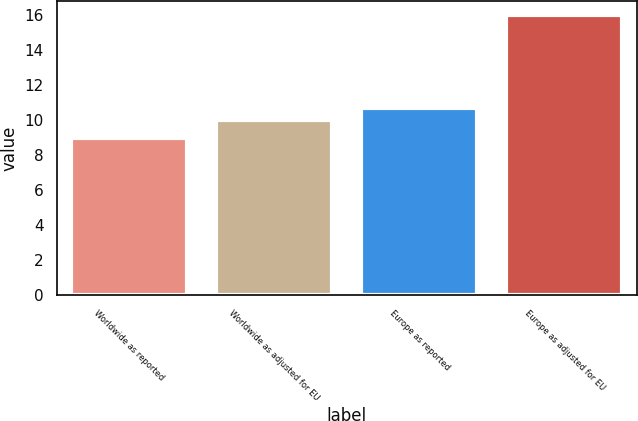Convert chart to OTSL. <chart><loc_0><loc_0><loc_500><loc_500><bar_chart><fcel>Worldwide as reported<fcel>Worldwide as adjusted for EU<fcel>Europe as reported<fcel>Europe as adjusted for EU<nl><fcel>9<fcel>10<fcel>10.7<fcel>16<nl></chart> 